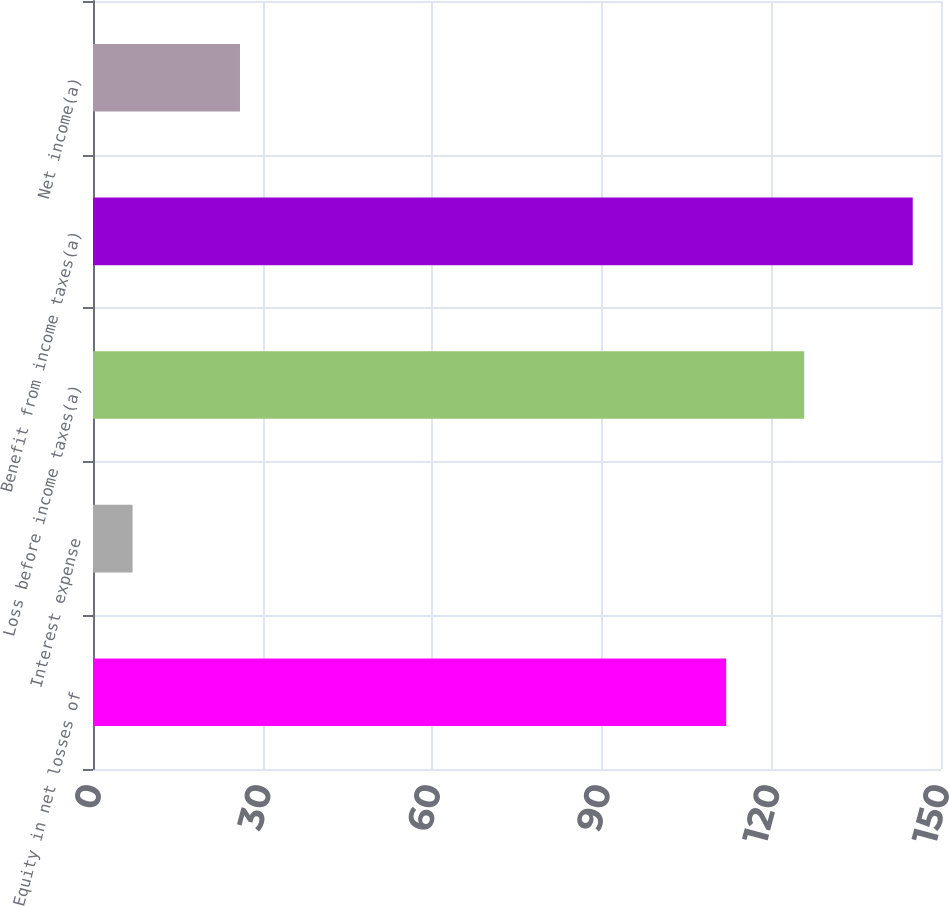Convert chart to OTSL. <chart><loc_0><loc_0><loc_500><loc_500><bar_chart><fcel>Equity in net losses of<fcel>Interest expense<fcel>Loss before income taxes(a)<fcel>Benefit from income taxes(a)<fcel>Net income(a)<nl><fcel>112<fcel>7<fcel>125.8<fcel>145<fcel>26<nl></chart> 